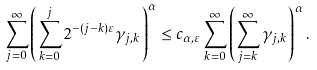Convert formula to latex. <formula><loc_0><loc_0><loc_500><loc_500>\sum _ { j = 0 } ^ { \infty } \left ( \sum _ { k = 0 } ^ { j } 2 ^ { - ( j - k ) \varepsilon } \gamma _ { j , k } \right ) ^ { \alpha } \leq c _ { \alpha , \varepsilon } \sum _ { k = 0 } ^ { \infty } \left ( \sum _ { j = k } ^ { \infty } \gamma _ { j , k } \right ) ^ { \alpha } .</formula> 